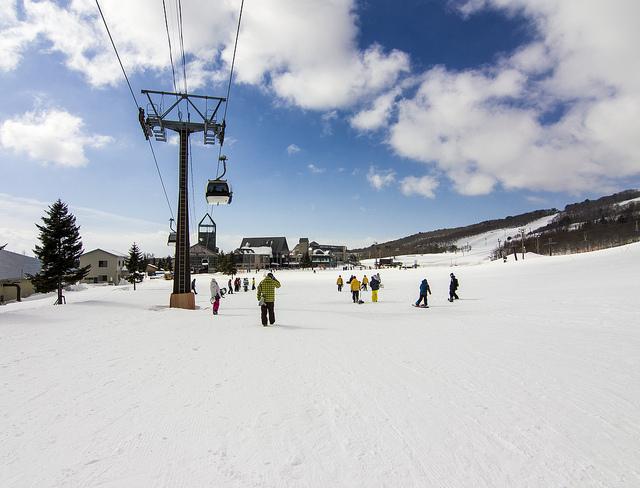What time is it?
Keep it brief. Daytime. IS the sun coming down?
Short answer required. No. What is he standing under?
Concise answer only. Ski lift. Is this picture colorful?
Answer briefly. Yes. Is anyone sitting down?
Quick response, please. No. What is the weather like?
Concise answer only. Cold. How many lifts are visible?
Give a very brief answer. 1. Is it a sunny day?
Write a very short answer. Yes. What number of mountains are in the distance?
Write a very short answer. 1. Do you know which parts of the ski lift are similar to a monorail?
Quick response, please. No. Are there clouds in the sky?
Give a very brief answer. Yes. What season is this?
Answer briefly. Winter. What is covering the ground?
Be succinct. Snow. 